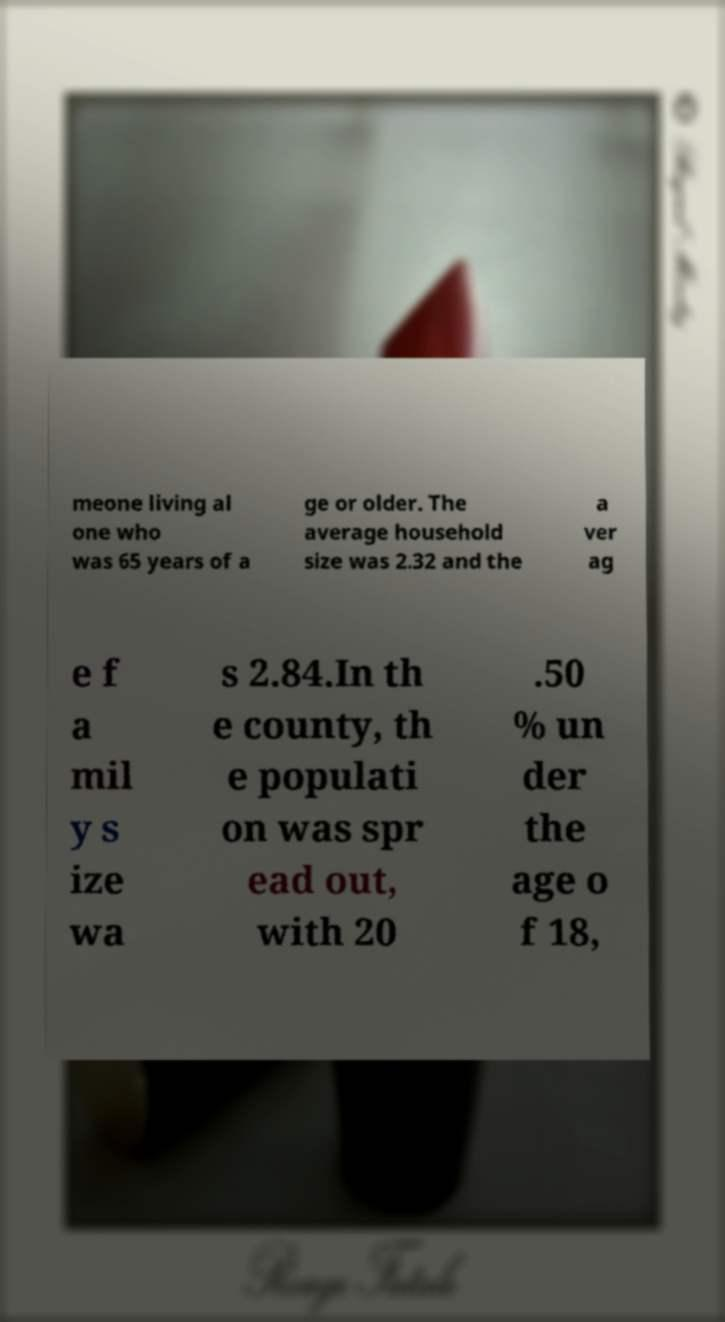Can you read and provide the text displayed in the image?This photo seems to have some interesting text. Can you extract and type it out for me? meone living al one who was 65 years of a ge or older. The average household size was 2.32 and the a ver ag e f a mil y s ize wa s 2.84.In th e county, th e populati on was spr ead out, with 20 .50 % un der the age o f 18, 